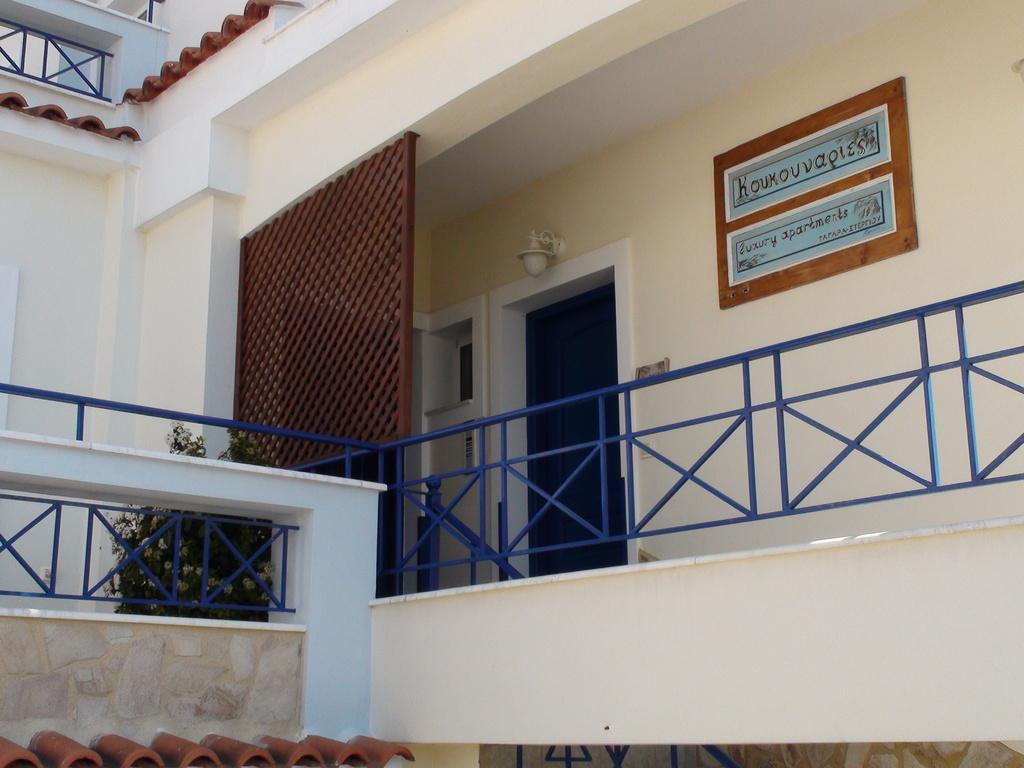What type of structure is visible in the image? There is a building in the image. Can you describe any specific features of the building? There is a nameplate on the wall of the building. What architectural element can be seen in the image? There are railings in the image. Are there any natural elements present in the image? Yes, there is a plant in the image. What grade is the student in the image? There is no student present in the image, so it is not possible to determine their grade. 